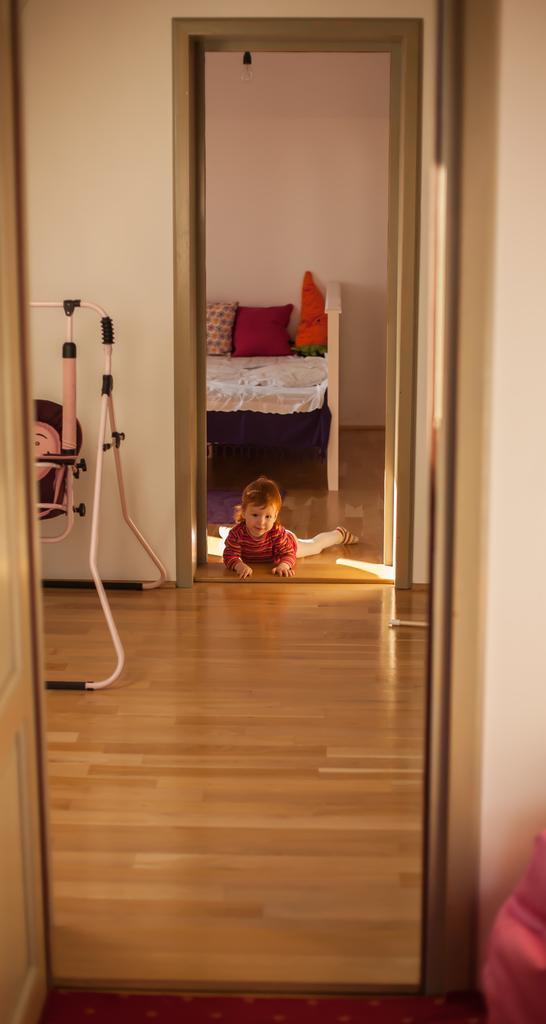How would you summarize this image in a sentence or two? This picture consists of a room where there is a baby at the center of the room lying on the floor and there is a bed at the left side of the image, there are pillows on the bed. 